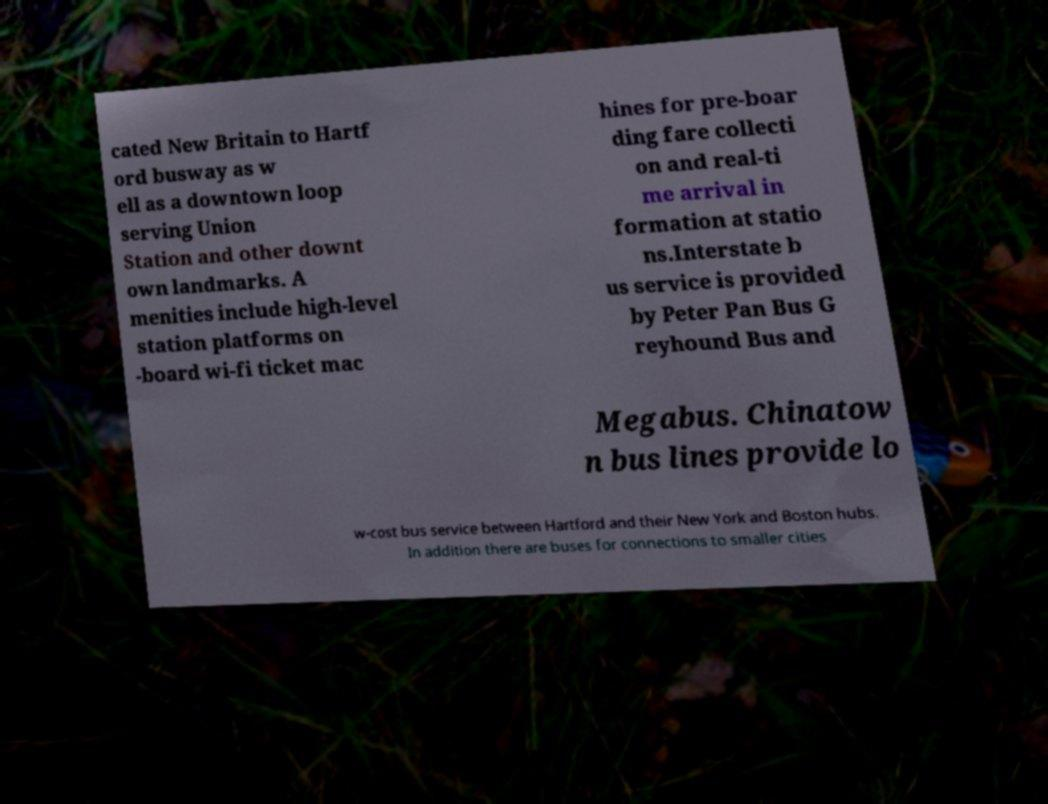Could you assist in decoding the text presented in this image and type it out clearly? cated New Britain to Hartf ord busway as w ell as a downtown loop serving Union Station and other downt own landmarks. A menities include high-level station platforms on -board wi-fi ticket mac hines for pre-boar ding fare collecti on and real-ti me arrival in formation at statio ns.Interstate b us service is provided by Peter Pan Bus G reyhound Bus and Megabus. Chinatow n bus lines provide lo w-cost bus service between Hartford and their New York and Boston hubs. In addition there are buses for connections to smaller cities 